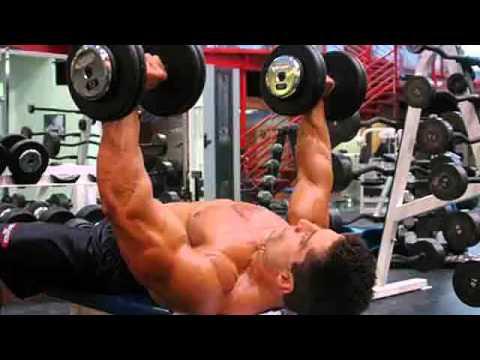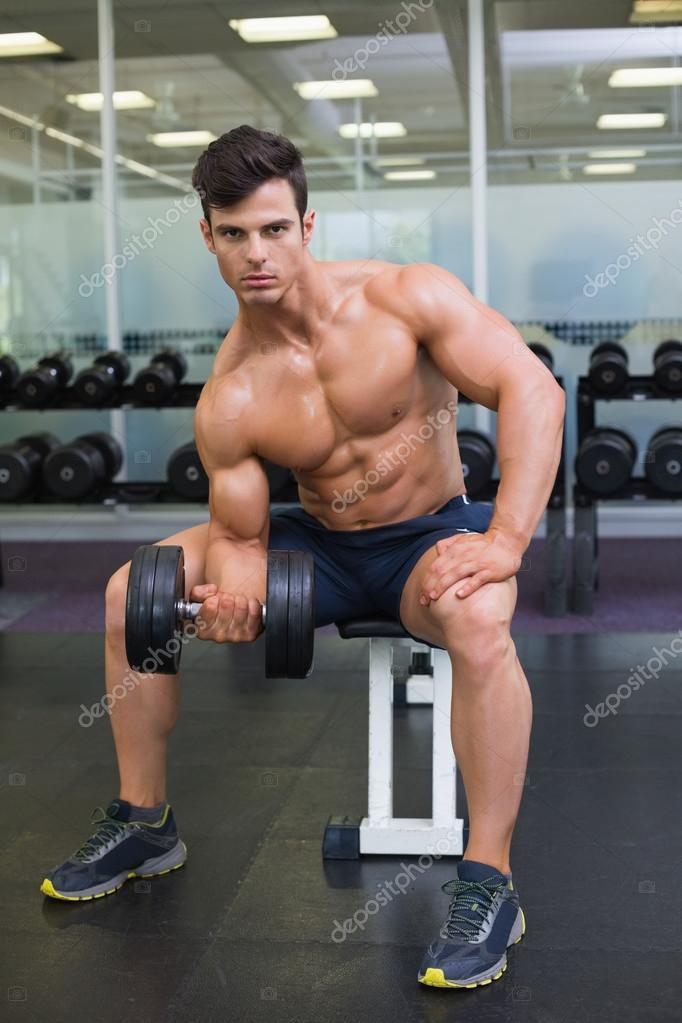The first image is the image on the left, the second image is the image on the right. Analyze the images presented: Is the assertion "Three dumbbells being held by men are visible." valid? Answer yes or no. Yes. The first image is the image on the left, the second image is the image on the right. For the images shown, is this caption "The front of a male torso is facing toward the camera in the left image." true? Answer yes or no. No. 